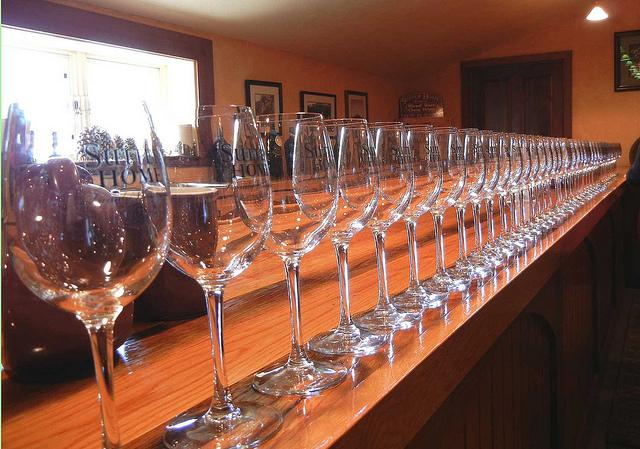What is lined up next to each other? wine glasses 